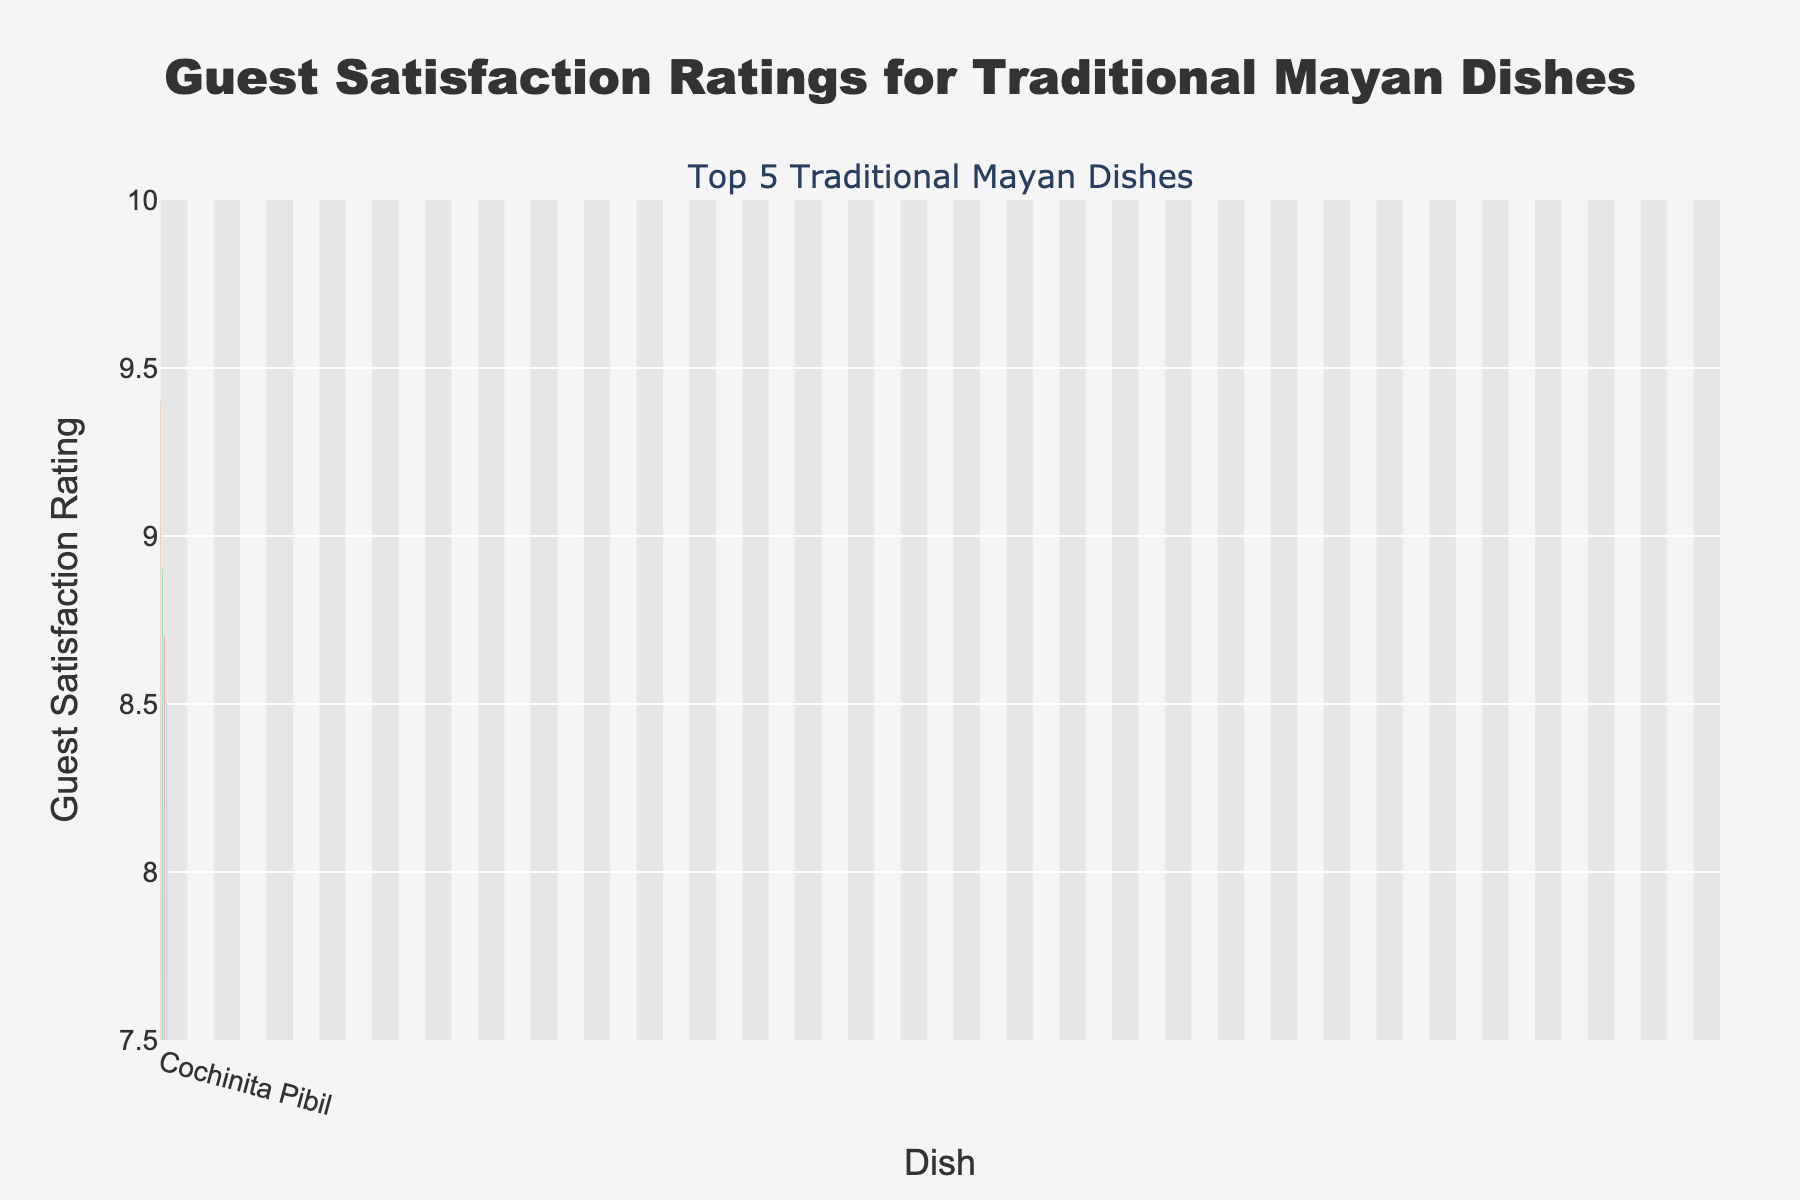what is the highest guest satisfaction rating on the bar chart? The highest guest satisfaction rating can be found by looking at the tallest bar in the chart, which corresponds to Cochinita Pibil. The satisfaction rating for Cochinita Pibil is 9.4.
Answer: 9.4 which traditional Mayan dish received the lowest guest satisfaction rating? To find the dish with the lowest rating, look for the shortest bar in the chart. The shortest bar corresponds to Tikin Xic, which has a satisfaction rating of 8.2.
Answer: Tikin Xic how much higher is the guest satisfaction rating for Cochinita Pibil compared to Tikin Xic? To determine the difference, subtract the rating of Tikin Xic (8.2) from the rating of Cochinita Pibil (9.4). This gives 9.4 - 8.2 = 1.2.
Answer: 1.2 what is the average guest satisfaction rating of all the dishes? Sum up all the ratings (9.4 + 8.9 + 8.7 + 8.5 + 8.2) to get 43.7. Divide by the number of dishes (5), so the average rating is 43.7 / 5 = 8.74.
Answer: 8.74 which dish has a guest satisfaction rating closest to the average rating of all dishes? Calculate the average (8.74) and find the dish with a satisfaction rating closest to this value. Sopa de Lima has a rating of 8.9, which is closest to 8.74.
Answer: Sopa de Lima how many dishes have a guest satisfaction rating above 8.5? Compare the ratings with 8.5 and count the number of dishes with higher ratings. Cochinita Pibil (9.4), Sopa de Lima (8.9), and Poc Chuc (8.7) are above this value, so there are 3 dishes.
Answer: 3 what is the combined guest satisfaction rating of the top 2 dishes? Add the ratings of the top 2 dishes: Cochinita Pibil (9.4) and Sopa de Lima (8.9). The sum is 9.4 + 8.9 = 18.3.
Answer: 18.3 which dish is represented with a green bar in the chart and what is its rating? The green bar corresponds to one of the traditional Mayan dishes. Sopa de Lima is represented by the green bar with a satisfaction rating of 8.9.
Answer: Sopa de Lima, 8.9 